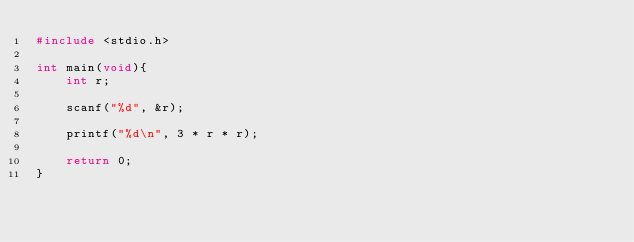Convert code to text. <code><loc_0><loc_0><loc_500><loc_500><_C_>#include <stdio.h>

int main(void){
    int r;

    scanf("%d", &r);

    printf("%d\n", 3 * r * r);

    return 0;
}</code> 